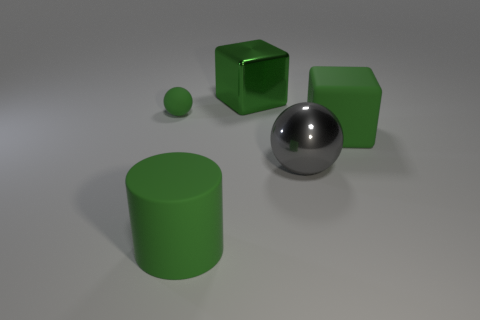Add 1 big green matte cubes. How many objects exist? 6 Subtract all green balls. How many balls are left? 1 Subtract all balls. How many objects are left? 3 Subtract 1 cubes. How many cubes are left? 1 Subtract all yellow blocks. Subtract all yellow spheres. How many blocks are left? 2 Subtract all red blocks. How many green balls are left? 1 Subtract all big brown matte cylinders. Subtract all tiny green balls. How many objects are left? 4 Add 3 green rubber balls. How many green rubber balls are left? 4 Add 1 tiny purple rubber blocks. How many tiny purple rubber blocks exist? 1 Subtract 0 brown cubes. How many objects are left? 5 